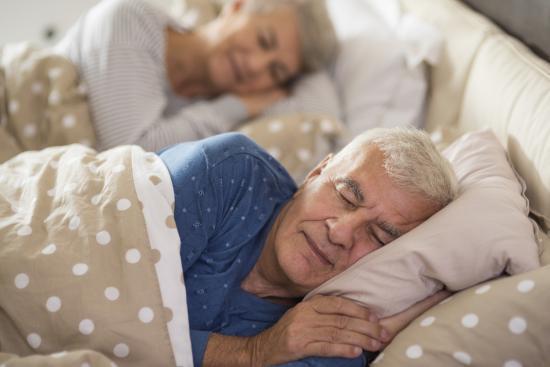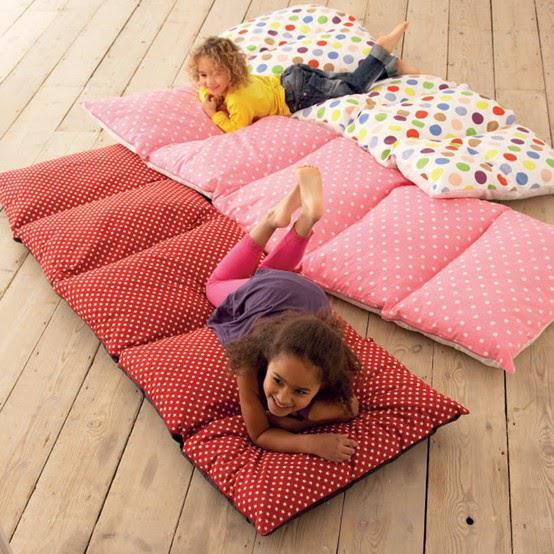The first image is the image on the left, the second image is the image on the right. Assess this claim about the two images: "The left image includes two people on some type of cushioned surface, and the right image features at least one little girl lying on her stomach on a mat consisting of several pillow sections.". Correct or not? Answer yes or no. Yes. The first image is the image on the left, the second image is the image on the right. Given the left and right images, does the statement "The right image contains two children." hold true? Answer yes or no. Yes. 